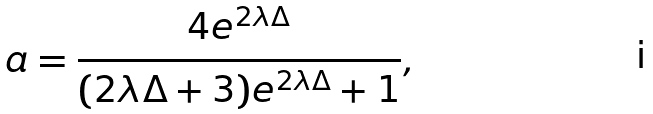Convert formula to latex. <formula><loc_0><loc_0><loc_500><loc_500>a = \frac { 4 e ^ { 2 \lambda \Delta } } { ( 2 \lambda \Delta + 3 ) e ^ { 2 \lambda \Delta } + 1 } ,</formula> 